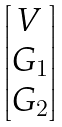<formula> <loc_0><loc_0><loc_500><loc_500>\begin{bmatrix} V \\ G _ { 1 } \\ G _ { 2 } \end{bmatrix}</formula> 